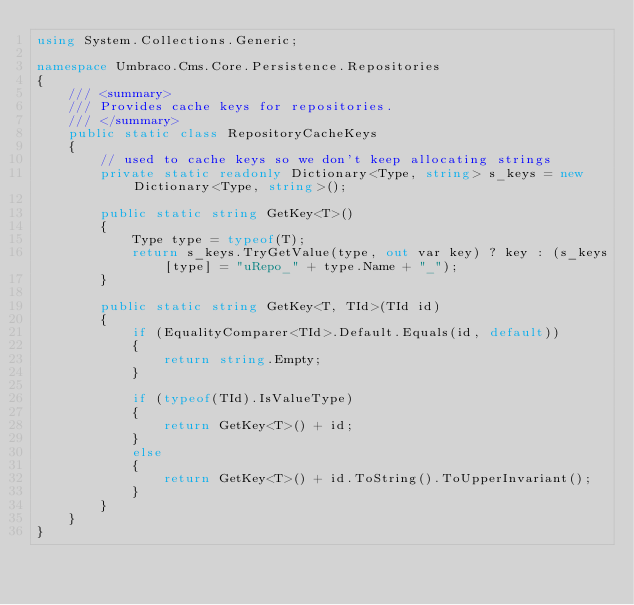<code> <loc_0><loc_0><loc_500><loc_500><_C#_>using System.Collections.Generic;

namespace Umbraco.Cms.Core.Persistence.Repositories
{
    /// <summary>
    /// Provides cache keys for repositories.
    /// </summary>
    public static class RepositoryCacheKeys
    {
        // used to cache keys so we don't keep allocating strings
        private static readonly Dictionary<Type, string> s_keys = new Dictionary<Type, string>();

        public static string GetKey<T>()
        {
            Type type = typeof(T);
            return s_keys.TryGetValue(type, out var key) ? key : (s_keys[type] = "uRepo_" + type.Name + "_");
        }

        public static string GetKey<T, TId>(TId id)
        {
            if (EqualityComparer<TId>.Default.Equals(id, default))
            {
                return string.Empty;
            }

            if (typeof(TId).IsValueType)
            {
                return GetKey<T>() + id;
            }
            else
            {
                return GetKey<T>() + id.ToString().ToUpperInvariant();
            }
        }
    }
}
</code> 